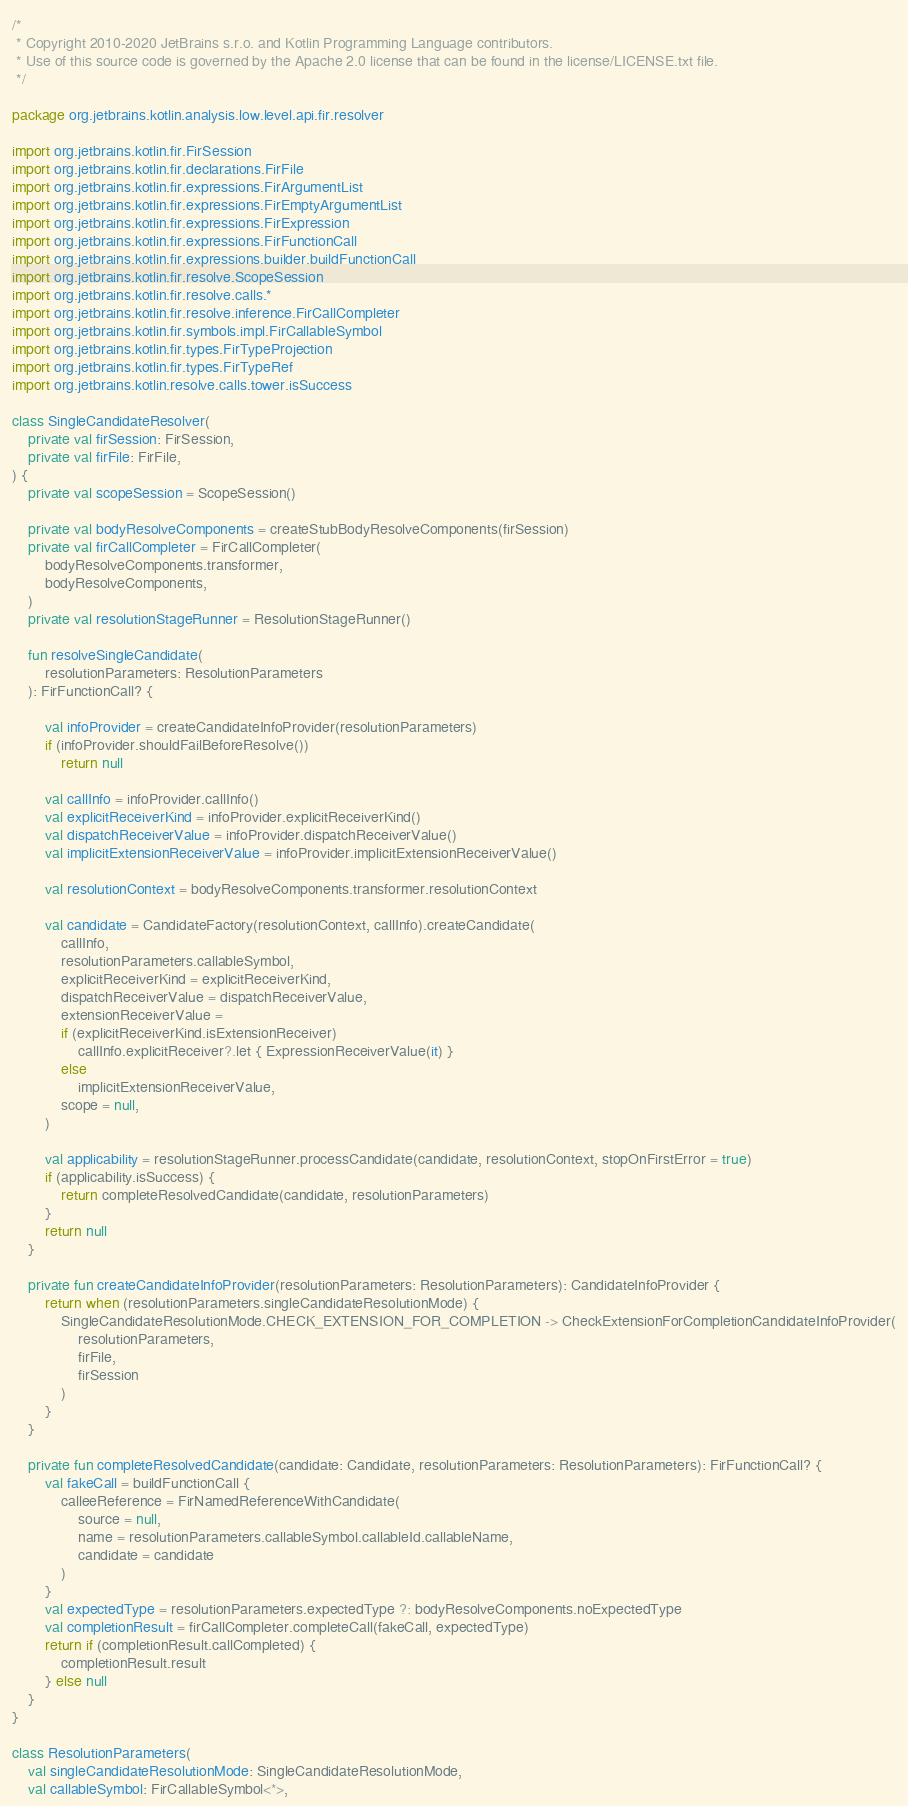<code> <loc_0><loc_0><loc_500><loc_500><_Kotlin_>/*
 * Copyright 2010-2020 JetBrains s.r.o. and Kotlin Programming Language contributors.
 * Use of this source code is governed by the Apache 2.0 license that can be found in the license/LICENSE.txt file.
 */

package org.jetbrains.kotlin.analysis.low.level.api.fir.resolver

import org.jetbrains.kotlin.fir.FirSession
import org.jetbrains.kotlin.fir.declarations.FirFile
import org.jetbrains.kotlin.fir.expressions.FirArgumentList
import org.jetbrains.kotlin.fir.expressions.FirEmptyArgumentList
import org.jetbrains.kotlin.fir.expressions.FirExpression
import org.jetbrains.kotlin.fir.expressions.FirFunctionCall
import org.jetbrains.kotlin.fir.expressions.builder.buildFunctionCall
import org.jetbrains.kotlin.fir.resolve.ScopeSession
import org.jetbrains.kotlin.fir.resolve.calls.*
import org.jetbrains.kotlin.fir.resolve.inference.FirCallCompleter
import org.jetbrains.kotlin.fir.symbols.impl.FirCallableSymbol
import org.jetbrains.kotlin.fir.types.FirTypeProjection
import org.jetbrains.kotlin.fir.types.FirTypeRef
import org.jetbrains.kotlin.resolve.calls.tower.isSuccess

class SingleCandidateResolver(
    private val firSession: FirSession,
    private val firFile: FirFile,
) {
    private val scopeSession = ScopeSession()

    private val bodyResolveComponents = createStubBodyResolveComponents(firSession)
    private val firCallCompleter = FirCallCompleter(
        bodyResolveComponents.transformer,
        bodyResolveComponents,
    )
    private val resolutionStageRunner = ResolutionStageRunner()

    fun resolveSingleCandidate(
        resolutionParameters: ResolutionParameters
    ): FirFunctionCall? {

        val infoProvider = createCandidateInfoProvider(resolutionParameters)
        if (infoProvider.shouldFailBeforeResolve())
            return null

        val callInfo = infoProvider.callInfo()
        val explicitReceiverKind = infoProvider.explicitReceiverKind()
        val dispatchReceiverValue = infoProvider.dispatchReceiverValue()
        val implicitExtensionReceiverValue = infoProvider.implicitExtensionReceiverValue()

        val resolutionContext = bodyResolveComponents.transformer.resolutionContext

        val candidate = CandidateFactory(resolutionContext, callInfo).createCandidate(
            callInfo,
            resolutionParameters.callableSymbol,
            explicitReceiverKind = explicitReceiverKind,
            dispatchReceiverValue = dispatchReceiverValue,
            extensionReceiverValue =
            if (explicitReceiverKind.isExtensionReceiver)
                callInfo.explicitReceiver?.let { ExpressionReceiverValue(it) }
            else
                implicitExtensionReceiverValue,
            scope = null,
        )

        val applicability = resolutionStageRunner.processCandidate(candidate, resolutionContext, stopOnFirstError = true)
        if (applicability.isSuccess) {
            return completeResolvedCandidate(candidate, resolutionParameters)
        }
        return null
    }

    private fun createCandidateInfoProvider(resolutionParameters: ResolutionParameters): CandidateInfoProvider {
        return when (resolutionParameters.singleCandidateResolutionMode) {
            SingleCandidateResolutionMode.CHECK_EXTENSION_FOR_COMPLETION -> CheckExtensionForCompletionCandidateInfoProvider(
                resolutionParameters,
                firFile,
                firSession
            )
        }
    }

    private fun completeResolvedCandidate(candidate: Candidate, resolutionParameters: ResolutionParameters): FirFunctionCall? {
        val fakeCall = buildFunctionCall {
            calleeReference = FirNamedReferenceWithCandidate(
                source = null,
                name = resolutionParameters.callableSymbol.callableId.callableName,
                candidate = candidate
            )
        }
        val expectedType = resolutionParameters.expectedType ?: bodyResolveComponents.noExpectedType
        val completionResult = firCallCompleter.completeCall(fakeCall, expectedType)
        return if (completionResult.callCompleted) {
            completionResult.result
        } else null
    }
}

class ResolutionParameters(
    val singleCandidateResolutionMode: SingleCandidateResolutionMode,
    val callableSymbol: FirCallableSymbol<*>,</code> 